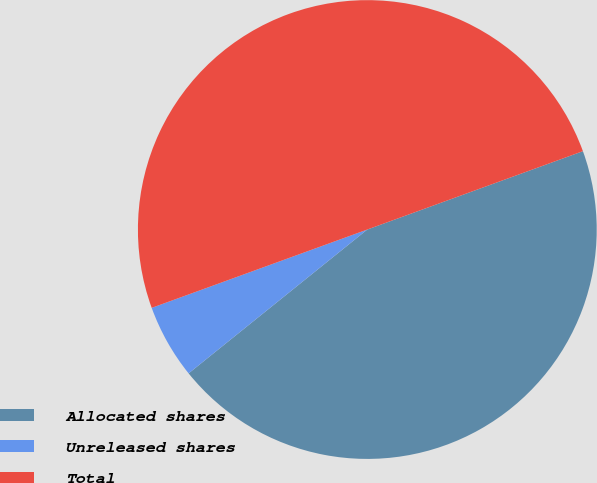<chart> <loc_0><loc_0><loc_500><loc_500><pie_chart><fcel>Allocated shares<fcel>Unreleased shares<fcel>Total<nl><fcel>44.76%<fcel>5.24%<fcel>50.0%<nl></chart> 